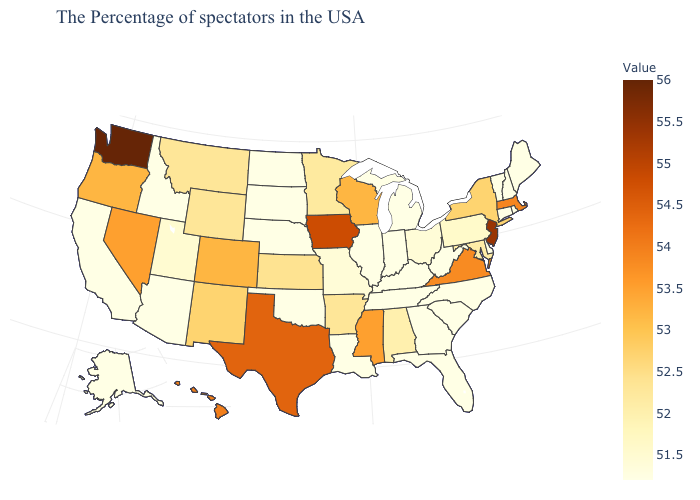Does Colorado have the highest value in the USA?
Write a very short answer. No. Among the states that border Rhode Island , does Massachusetts have the highest value?
Be succinct. Yes. Does New Hampshire have the highest value in the Northeast?
Quick response, please. No. Does the map have missing data?
Be succinct. No. Which states have the lowest value in the Northeast?
Concise answer only. Maine, Rhode Island, New Hampshire, Vermont, Connecticut. 